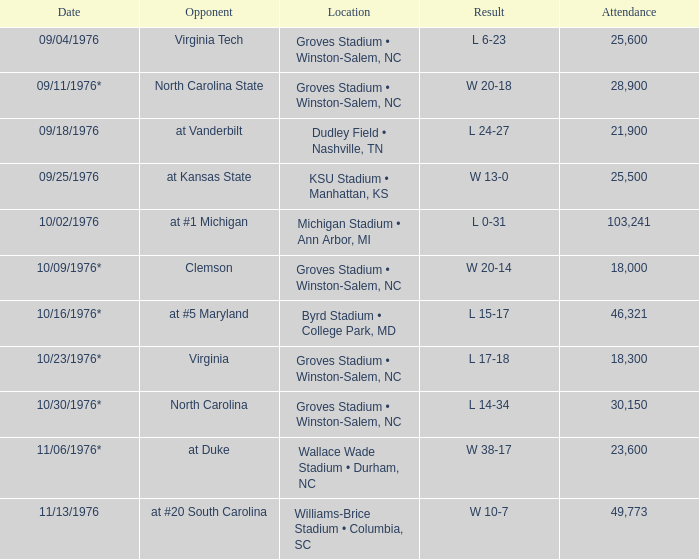What was the specific date for the game against north carolina? 10/30/1976*. 